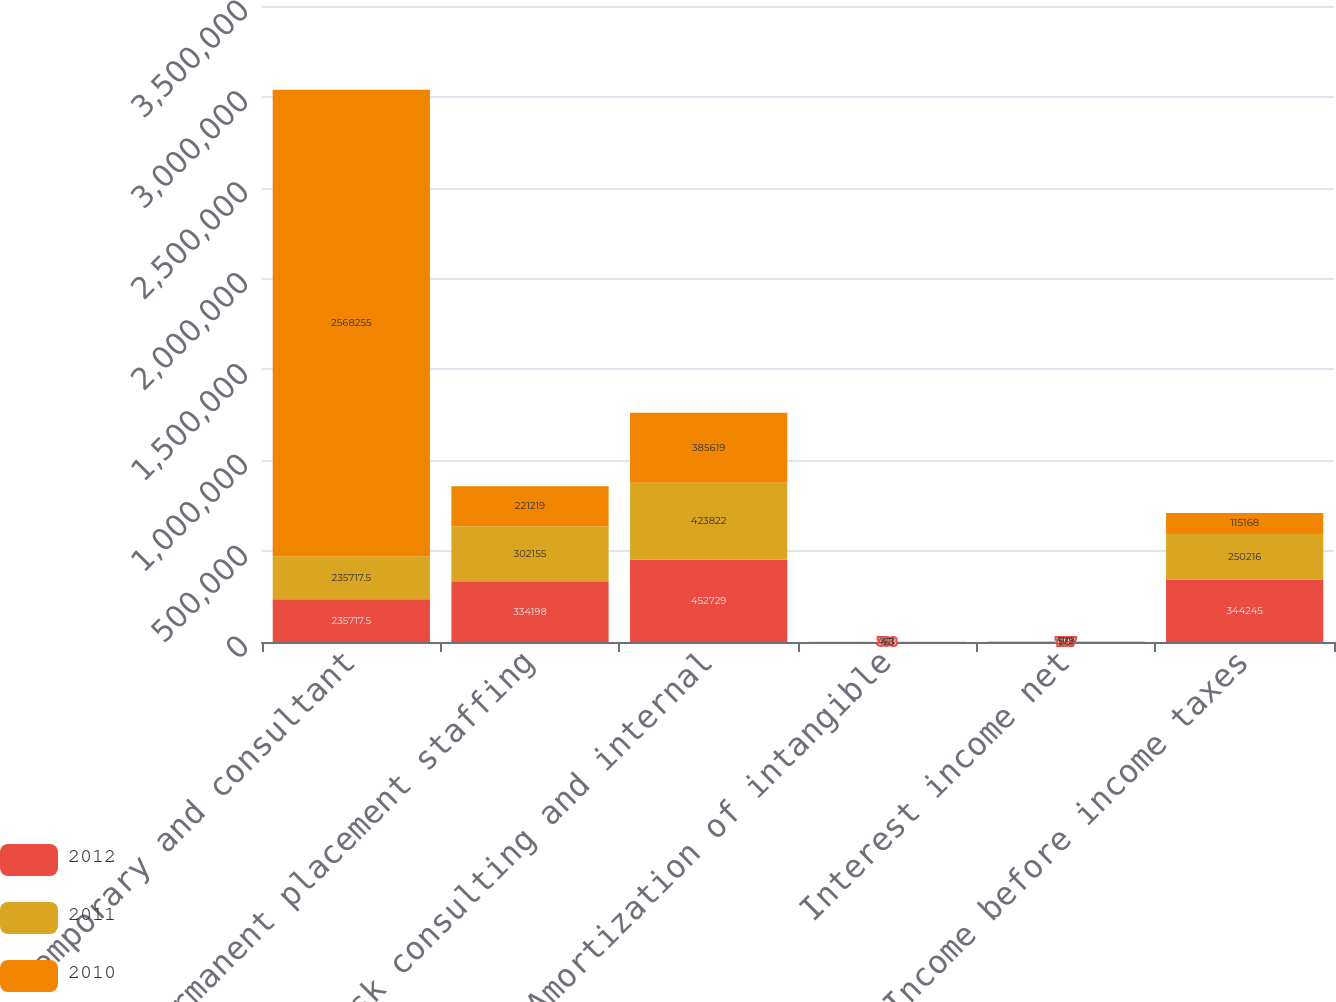<chart> <loc_0><loc_0><loc_500><loc_500><stacked_bar_chart><ecel><fcel>Temporary and consultant<fcel>Permanent placement staffing<fcel>Risk consulting and internal<fcel>Amortization of intangible<fcel>Interest income net<fcel>Income before income taxes<nl><fcel>2012<fcel>235718<fcel>334198<fcel>452729<fcel>398<fcel>1197<fcel>344245<nl><fcel>2011<fcel>235718<fcel>302155<fcel>423822<fcel>153<fcel>951<fcel>250216<nl><fcel>2010<fcel>2.56826e+06<fcel>221219<fcel>385619<fcel>411<fcel>579<fcel>115168<nl></chart> 